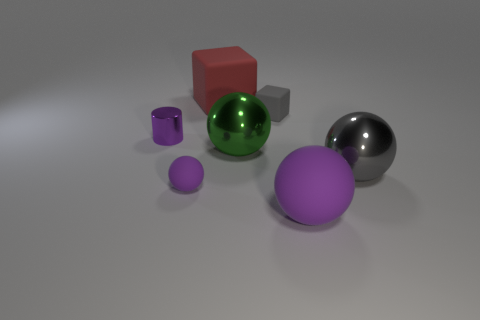There is a purple thing right of the small rubber thing that is to the left of the red block; what shape is it? sphere 